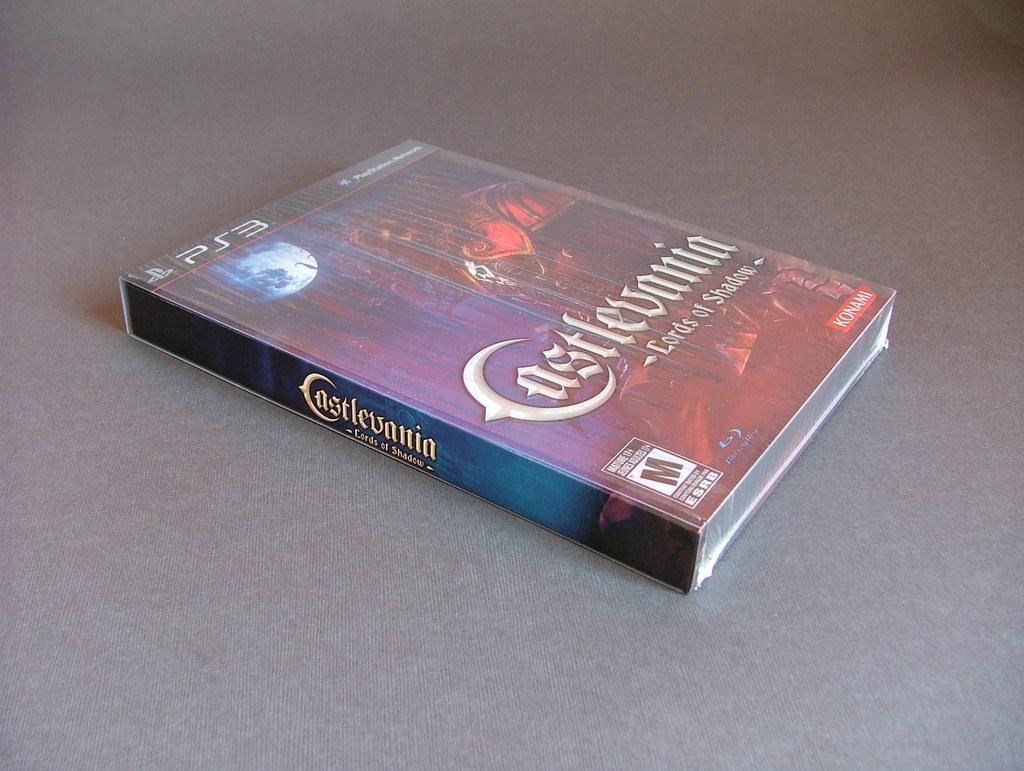<image>
Provide a brief description of the given image. A PS3 game, Castlevania, sits on a table. 